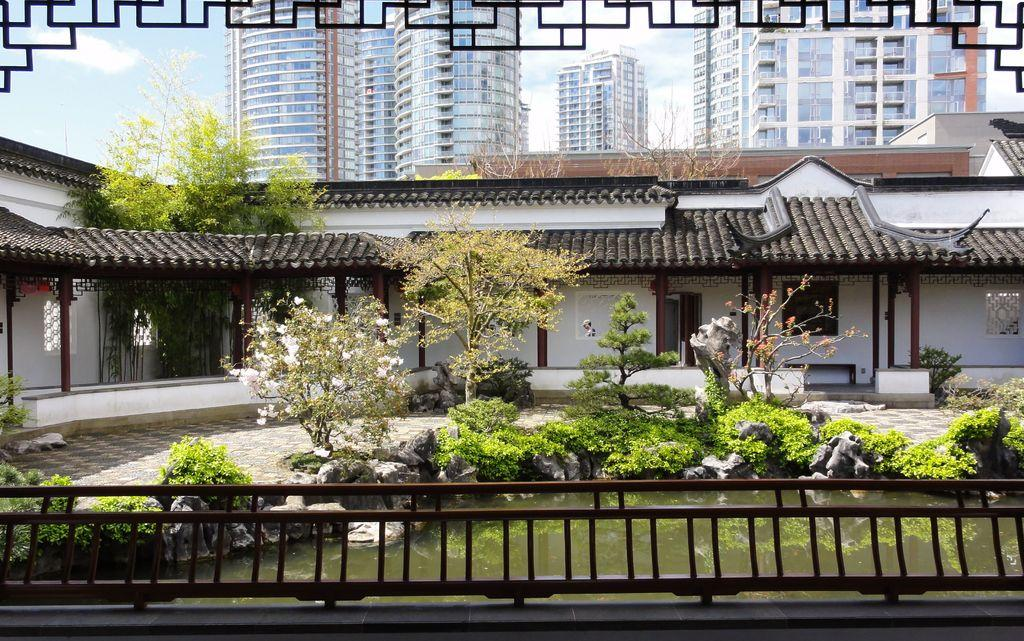What type of structures can be seen in the image? There are buildings in the image. What type of vegetation is present in the image? There are trees and plants in the image. What natural element is visible in the image? There is water visible in the image. How would you describe the sky in the image? The sky is blue and cloudy in the image. What type of medical advice can be heard from the doctor in the image? There is no doctor present in the image, so no medical advice can be heard. 